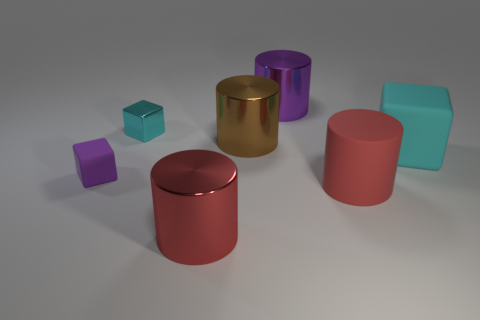What number of things are either small cubes or rubber objects that are on the left side of the large brown thing?
Your answer should be very brief. 2. Are there more big cylinders in front of the big purple thing than tiny cyan rubber objects?
Keep it short and to the point. Yes. Is the number of big red things on the right side of the big cyan thing the same as the number of things that are behind the large purple cylinder?
Offer a terse response. Yes. Are there any cylinders that are behind the cyan block that is behind the big cyan object?
Offer a terse response. Yes. The small purple rubber object is what shape?
Your answer should be very brief. Cube. The shiny cylinder that is the same color as the small matte block is what size?
Your response must be concise. Large. There is a rubber cube that is right of the cylinder on the right side of the purple metallic cylinder; what size is it?
Provide a succinct answer. Large. There is a red object to the right of the red shiny thing; what size is it?
Provide a short and direct response. Large. Is the number of large matte things that are on the left side of the tiny rubber thing less than the number of purple objects in front of the large cyan cube?
Your answer should be very brief. Yes. What is the color of the rubber cylinder?
Your answer should be compact. Red. 